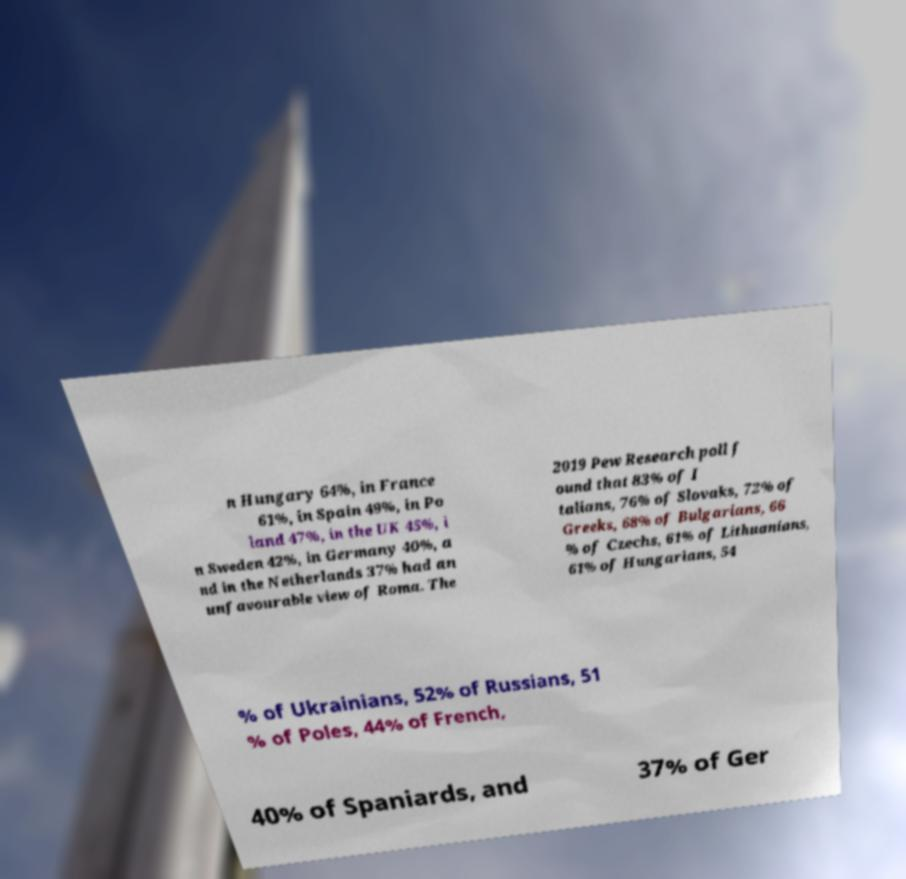Could you extract and type out the text from this image? n Hungary 64%, in France 61%, in Spain 49%, in Po land 47%, in the UK 45%, i n Sweden 42%, in Germany 40%, a nd in the Netherlands 37% had an unfavourable view of Roma. The 2019 Pew Research poll f ound that 83% of I talians, 76% of Slovaks, 72% of Greeks, 68% of Bulgarians, 66 % of Czechs, 61% of Lithuanians, 61% of Hungarians, 54 % of Ukrainians, 52% of Russians, 51 % of Poles, 44% of French, 40% of Spaniards, and 37% of Ger 